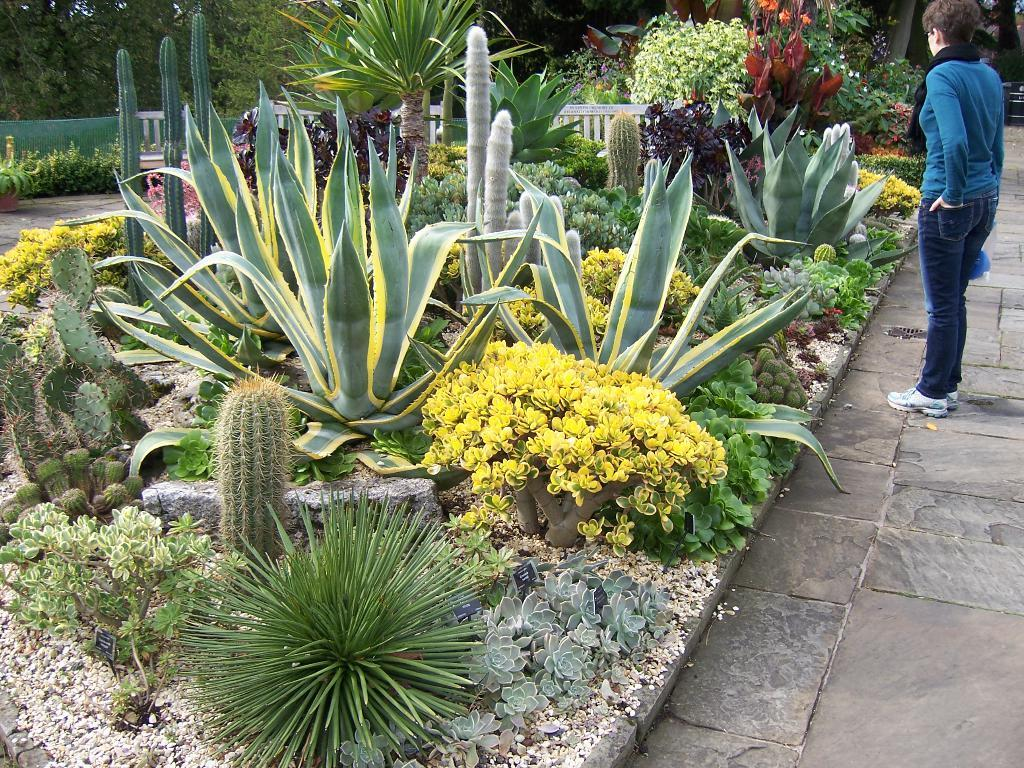What is the main subject of the image? There is a person standing in the image. What can be seen in the image besides the person? There are plants, flowers, a fence, and trees in the background of the image. What is the person's income in the image? There is no information about the person's income in the image. Is there a prison visible in the image? There is no prison present in the image. 